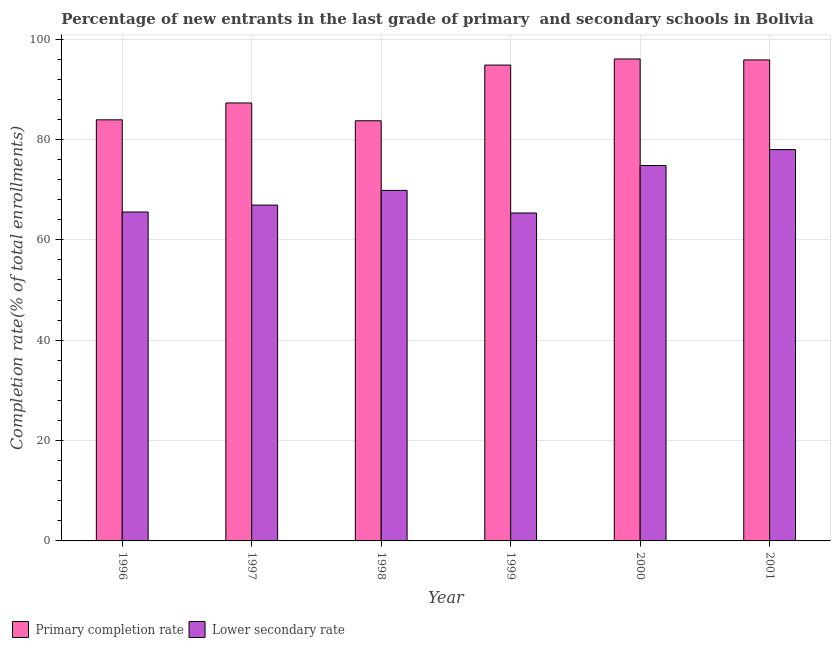Are the number of bars per tick equal to the number of legend labels?
Keep it short and to the point. Yes. How many bars are there on the 1st tick from the left?
Give a very brief answer. 2. How many bars are there on the 3rd tick from the right?
Provide a short and direct response. 2. In how many cases, is the number of bars for a given year not equal to the number of legend labels?
Provide a succinct answer. 0. What is the completion rate in primary schools in 1999?
Give a very brief answer. 94.83. Across all years, what is the maximum completion rate in secondary schools?
Your answer should be compact. 77.98. Across all years, what is the minimum completion rate in primary schools?
Offer a terse response. 83.73. In which year was the completion rate in secondary schools maximum?
Your answer should be compact. 2001. In which year was the completion rate in primary schools minimum?
Your response must be concise. 1998. What is the total completion rate in secondary schools in the graph?
Keep it short and to the point. 420.45. What is the difference between the completion rate in secondary schools in 1999 and that in 2000?
Provide a short and direct response. -9.46. What is the difference between the completion rate in secondary schools in 1997 and the completion rate in primary schools in 1998?
Offer a very short reply. -2.93. What is the average completion rate in primary schools per year?
Make the answer very short. 90.27. In how many years, is the completion rate in secondary schools greater than 72 %?
Make the answer very short. 2. What is the ratio of the completion rate in primary schools in 1997 to that in 2001?
Offer a terse response. 0.91. Is the difference between the completion rate in secondary schools in 1999 and 2000 greater than the difference between the completion rate in primary schools in 1999 and 2000?
Give a very brief answer. No. What is the difference between the highest and the second highest completion rate in secondary schools?
Provide a succinct answer. 3.18. What is the difference between the highest and the lowest completion rate in secondary schools?
Make the answer very short. 12.64. In how many years, is the completion rate in primary schools greater than the average completion rate in primary schools taken over all years?
Make the answer very short. 3. What does the 1st bar from the left in 1997 represents?
Provide a succinct answer. Primary completion rate. What does the 2nd bar from the right in 1996 represents?
Ensure brevity in your answer.  Primary completion rate. How many years are there in the graph?
Offer a very short reply. 6. What is the difference between two consecutive major ticks on the Y-axis?
Give a very brief answer. 20. Does the graph contain any zero values?
Your answer should be compact. No. Where does the legend appear in the graph?
Give a very brief answer. Bottom left. How many legend labels are there?
Ensure brevity in your answer.  2. What is the title of the graph?
Offer a terse response. Percentage of new entrants in the last grade of primary  and secondary schools in Bolivia. What is the label or title of the X-axis?
Offer a very short reply. Year. What is the label or title of the Y-axis?
Offer a very short reply. Completion rate(% of total enrollments). What is the Completion rate(% of total enrollments) in Primary completion rate in 1996?
Keep it short and to the point. 83.92. What is the Completion rate(% of total enrollments) in Lower secondary rate in 1996?
Provide a succinct answer. 65.54. What is the Completion rate(% of total enrollments) of Primary completion rate in 1997?
Keep it short and to the point. 87.28. What is the Completion rate(% of total enrollments) of Lower secondary rate in 1997?
Ensure brevity in your answer.  66.92. What is the Completion rate(% of total enrollments) in Primary completion rate in 1998?
Offer a very short reply. 83.73. What is the Completion rate(% of total enrollments) of Lower secondary rate in 1998?
Ensure brevity in your answer.  69.85. What is the Completion rate(% of total enrollments) in Primary completion rate in 1999?
Give a very brief answer. 94.83. What is the Completion rate(% of total enrollments) of Lower secondary rate in 1999?
Your answer should be very brief. 65.35. What is the Completion rate(% of total enrollments) of Primary completion rate in 2000?
Ensure brevity in your answer.  96.04. What is the Completion rate(% of total enrollments) in Lower secondary rate in 2000?
Make the answer very short. 74.8. What is the Completion rate(% of total enrollments) in Primary completion rate in 2001?
Make the answer very short. 95.85. What is the Completion rate(% of total enrollments) of Lower secondary rate in 2001?
Your response must be concise. 77.98. Across all years, what is the maximum Completion rate(% of total enrollments) in Primary completion rate?
Provide a succinct answer. 96.04. Across all years, what is the maximum Completion rate(% of total enrollments) of Lower secondary rate?
Give a very brief answer. 77.98. Across all years, what is the minimum Completion rate(% of total enrollments) of Primary completion rate?
Give a very brief answer. 83.73. Across all years, what is the minimum Completion rate(% of total enrollments) in Lower secondary rate?
Ensure brevity in your answer.  65.35. What is the total Completion rate(% of total enrollments) of Primary completion rate in the graph?
Your answer should be compact. 541.64. What is the total Completion rate(% of total enrollments) of Lower secondary rate in the graph?
Provide a succinct answer. 420.45. What is the difference between the Completion rate(% of total enrollments) in Primary completion rate in 1996 and that in 1997?
Give a very brief answer. -3.36. What is the difference between the Completion rate(% of total enrollments) in Lower secondary rate in 1996 and that in 1997?
Keep it short and to the point. -1.38. What is the difference between the Completion rate(% of total enrollments) in Primary completion rate in 1996 and that in 1998?
Make the answer very short. 0.19. What is the difference between the Completion rate(% of total enrollments) of Lower secondary rate in 1996 and that in 1998?
Offer a very short reply. -4.31. What is the difference between the Completion rate(% of total enrollments) in Primary completion rate in 1996 and that in 1999?
Provide a succinct answer. -10.91. What is the difference between the Completion rate(% of total enrollments) in Lower secondary rate in 1996 and that in 1999?
Offer a very short reply. 0.2. What is the difference between the Completion rate(% of total enrollments) of Primary completion rate in 1996 and that in 2000?
Offer a very short reply. -12.13. What is the difference between the Completion rate(% of total enrollments) of Lower secondary rate in 1996 and that in 2000?
Give a very brief answer. -9.26. What is the difference between the Completion rate(% of total enrollments) in Primary completion rate in 1996 and that in 2001?
Make the answer very short. -11.93. What is the difference between the Completion rate(% of total enrollments) of Lower secondary rate in 1996 and that in 2001?
Offer a terse response. -12.44. What is the difference between the Completion rate(% of total enrollments) of Primary completion rate in 1997 and that in 1998?
Your answer should be compact. 3.55. What is the difference between the Completion rate(% of total enrollments) in Lower secondary rate in 1997 and that in 1998?
Provide a short and direct response. -2.93. What is the difference between the Completion rate(% of total enrollments) in Primary completion rate in 1997 and that in 1999?
Ensure brevity in your answer.  -7.55. What is the difference between the Completion rate(% of total enrollments) of Lower secondary rate in 1997 and that in 1999?
Your answer should be very brief. 1.58. What is the difference between the Completion rate(% of total enrollments) of Primary completion rate in 1997 and that in 2000?
Ensure brevity in your answer.  -8.77. What is the difference between the Completion rate(% of total enrollments) of Lower secondary rate in 1997 and that in 2000?
Offer a terse response. -7.88. What is the difference between the Completion rate(% of total enrollments) of Primary completion rate in 1997 and that in 2001?
Make the answer very short. -8.57. What is the difference between the Completion rate(% of total enrollments) in Lower secondary rate in 1997 and that in 2001?
Your answer should be compact. -11.06. What is the difference between the Completion rate(% of total enrollments) of Primary completion rate in 1998 and that in 1999?
Your answer should be very brief. -11.1. What is the difference between the Completion rate(% of total enrollments) in Lower secondary rate in 1998 and that in 1999?
Make the answer very short. 4.51. What is the difference between the Completion rate(% of total enrollments) of Primary completion rate in 1998 and that in 2000?
Offer a very short reply. -12.31. What is the difference between the Completion rate(% of total enrollments) in Lower secondary rate in 1998 and that in 2000?
Ensure brevity in your answer.  -4.95. What is the difference between the Completion rate(% of total enrollments) of Primary completion rate in 1998 and that in 2001?
Offer a terse response. -12.12. What is the difference between the Completion rate(% of total enrollments) in Lower secondary rate in 1998 and that in 2001?
Your answer should be compact. -8.13. What is the difference between the Completion rate(% of total enrollments) of Primary completion rate in 1999 and that in 2000?
Provide a short and direct response. -1.21. What is the difference between the Completion rate(% of total enrollments) in Lower secondary rate in 1999 and that in 2000?
Keep it short and to the point. -9.46. What is the difference between the Completion rate(% of total enrollments) of Primary completion rate in 1999 and that in 2001?
Keep it short and to the point. -1.02. What is the difference between the Completion rate(% of total enrollments) of Lower secondary rate in 1999 and that in 2001?
Offer a terse response. -12.64. What is the difference between the Completion rate(% of total enrollments) in Primary completion rate in 2000 and that in 2001?
Your response must be concise. 0.19. What is the difference between the Completion rate(% of total enrollments) in Lower secondary rate in 2000 and that in 2001?
Your answer should be compact. -3.18. What is the difference between the Completion rate(% of total enrollments) in Primary completion rate in 1996 and the Completion rate(% of total enrollments) in Lower secondary rate in 1997?
Ensure brevity in your answer.  16.99. What is the difference between the Completion rate(% of total enrollments) of Primary completion rate in 1996 and the Completion rate(% of total enrollments) of Lower secondary rate in 1998?
Offer a terse response. 14.06. What is the difference between the Completion rate(% of total enrollments) of Primary completion rate in 1996 and the Completion rate(% of total enrollments) of Lower secondary rate in 1999?
Offer a terse response. 18.57. What is the difference between the Completion rate(% of total enrollments) of Primary completion rate in 1996 and the Completion rate(% of total enrollments) of Lower secondary rate in 2000?
Provide a short and direct response. 9.11. What is the difference between the Completion rate(% of total enrollments) of Primary completion rate in 1996 and the Completion rate(% of total enrollments) of Lower secondary rate in 2001?
Offer a very short reply. 5.93. What is the difference between the Completion rate(% of total enrollments) in Primary completion rate in 1997 and the Completion rate(% of total enrollments) in Lower secondary rate in 1998?
Ensure brevity in your answer.  17.42. What is the difference between the Completion rate(% of total enrollments) in Primary completion rate in 1997 and the Completion rate(% of total enrollments) in Lower secondary rate in 1999?
Provide a succinct answer. 21.93. What is the difference between the Completion rate(% of total enrollments) in Primary completion rate in 1997 and the Completion rate(% of total enrollments) in Lower secondary rate in 2000?
Provide a short and direct response. 12.47. What is the difference between the Completion rate(% of total enrollments) of Primary completion rate in 1997 and the Completion rate(% of total enrollments) of Lower secondary rate in 2001?
Your answer should be compact. 9.29. What is the difference between the Completion rate(% of total enrollments) in Primary completion rate in 1998 and the Completion rate(% of total enrollments) in Lower secondary rate in 1999?
Ensure brevity in your answer.  18.38. What is the difference between the Completion rate(% of total enrollments) of Primary completion rate in 1998 and the Completion rate(% of total enrollments) of Lower secondary rate in 2000?
Keep it short and to the point. 8.92. What is the difference between the Completion rate(% of total enrollments) in Primary completion rate in 1998 and the Completion rate(% of total enrollments) in Lower secondary rate in 2001?
Keep it short and to the point. 5.75. What is the difference between the Completion rate(% of total enrollments) in Primary completion rate in 1999 and the Completion rate(% of total enrollments) in Lower secondary rate in 2000?
Provide a succinct answer. 20.02. What is the difference between the Completion rate(% of total enrollments) of Primary completion rate in 1999 and the Completion rate(% of total enrollments) of Lower secondary rate in 2001?
Make the answer very short. 16.84. What is the difference between the Completion rate(% of total enrollments) in Primary completion rate in 2000 and the Completion rate(% of total enrollments) in Lower secondary rate in 2001?
Make the answer very short. 18.06. What is the average Completion rate(% of total enrollments) of Primary completion rate per year?
Your answer should be compact. 90.27. What is the average Completion rate(% of total enrollments) of Lower secondary rate per year?
Ensure brevity in your answer.  70.07. In the year 1996, what is the difference between the Completion rate(% of total enrollments) in Primary completion rate and Completion rate(% of total enrollments) in Lower secondary rate?
Provide a short and direct response. 18.37. In the year 1997, what is the difference between the Completion rate(% of total enrollments) in Primary completion rate and Completion rate(% of total enrollments) in Lower secondary rate?
Give a very brief answer. 20.35. In the year 1998, what is the difference between the Completion rate(% of total enrollments) of Primary completion rate and Completion rate(% of total enrollments) of Lower secondary rate?
Give a very brief answer. 13.88. In the year 1999, what is the difference between the Completion rate(% of total enrollments) in Primary completion rate and Completion rate(% of total enrollments) in Lower secondary rate?
Provide a short and direct response. 29.48. In the year 2000, what is the difference between the Completion rate(% of total enrollments) in Primary completion rate and Completion rate(% of total enrollments) in Lower secondary rate?
Your answer should be compact. 21.24. In the year 2001, what is the difference between the Completion rate(% of total enrollments) of Primary completion rate and Completion rate(% of total enrollments) of Lower secondary rate?
Make the answer very short. 17.87. What is the ratio of the Completion rate(% of total enrollments) of Primary completion rate in 1996 to that in 1997?
Provide a succinct answer. 0.96. What is the ratio of the Completion rate(% of total enrollments) in Lower secondary rate in 1996 to that in 1997?
Offer a very short reply. 0.98. What is the ratio of the Completion rate(% of total enrollments) in Primary completion rate in 1996 to that in 1998?
Offer a terse response. 1. What is the ratio of the Completion rate(% of total enrollments) of Lower secondary rate in 1996 to that in 1998?
Ensure brevity in your answer.  0.94. What is the ratio of the Completion rate(% of total enrollments) in Primary completion rate in 1996 to that in 1999?
Offer a terse response. 0.88. What is the ratio of the Completion rate(% of total enrollments) of Lower secondary rate in 1996 to that in 1999?
Your response must be concise. 1. What is the ratio of the Completion rate(% of total enrollments) of Primary completion rate in 1996 to that in 2000?
Your answer should be very brief. 0.87. What is the ratio of the Completion rate(% of total enrollments) in Lower secondary rate in 1996 to that in 2000?
Keep it short and to the point. 0.88. What is the ratio of the Completion rate(% of total enrollments) of Primary completion rate in 1996 to that in 2001?
Provide a short and direct response. 0.88. What is the ratio of the Completion rate(% of total enrollments) in Lower secondary rate in 1996 to that in 2001?
Provide a succinct answer. 0.84. What is the ratio of the Completion rate(% of total enrollments) in Primary completion rate in 1997 to that in 1998?
Keep it short and to the point. 1.04. What is the ratio of the Completion rate(% of total enrollments) in Lower secondary rate in 1997 to that in 1998?
Your response must be concise. 0.96. What is the ratio of the Completion rate(% of total enrollments) of Primary completion rate in 1997 to that in 1999?
Make the answer very short. 0.92. What is the ratio of the Completion rate(% of total enrollments) of Lower secondary rate in 1997 to that in 1999?
Provide a succinct answer. 1.02. What is the ratio of the Completion rate(% of total enrollments) in Primary completion rate in 1997 to that in 2000?
Ensure brevity in your answer.  0.91. What is the ratio of the Completion rate(% of total enrollments) of Lower secondary rate in 1997 to that in 2000?
Provide a succinct answer. 0.89. What is the ratio of the Completion rate(% of total enrollments) of Primary completion rate in 1997 to that in 2001?
Provide a short and direct response. 0.91. What is the ratio of the Completion rate(% of total enrollments) of Lower secondary rate in 1997 to that in 2001?
Make the answer very short. 0.86. What is the ratio of the Completion rate(% of total enrollments) in Primary completion rate in 1998 to that in 1999?
Provide a succinct answer. 0.88. What is the ratio of the Completion rate(% of total enrollments) in Lower secondary rate in 1998 to that in 1999?
Offer a very short reply. 1.07. What is the ratio of the Completion rate(% of total enrollments) in Primary completion rate in 1998 to that in 2000?
Your response must be concise. 0.87. What is the ratio of the Completion rate(% of total enrollments) in Lower secondary rate in 1998 to that in 2000?
Provide a succinct answer. 0.93. What is the ratio of the Completion rate(% of total enrollments) of Primary completion rate in 1998 to that in 2001?
Ensure brevity in your answer.  0.87. What is the ratio of the Completion rate(% of total enrollments) in Lower secondary rate in 1998 to that in 2001?
Offer a very short reply. 0.9. What is the ratio of the Completion rate(% of total enrollments) of Primary completion rate in 1999 to that in 2000?
Your answer should be very brief. 0.99. What is the ratio of the Completion rate(% of total enrollments) in Lower secondary rate in 1999 to that in 2000?
Provide a succinct answer. 0.87. What is the ratio of the Completion rate(% of total enrollments) in Primary completion rate in 1999 to that in 2001?
Offer a terse response. 0.99. What is the ratio of the Completion rate(% of total enrollments) of Lower secondary rate in 1999 to that in 2001?
Give a very brief answer. 0.84. What is the ratio of the Completion rate(% of total enrollments) of Lower secondary rate in 2000 to that in 2001?
Provide a short and direct response. 0.96. What is the difference between the highest and the second highest Completion rate(% of total enrollments) in Primary completion rate?
Your answer should be very brief. 0.19. What is the difference between the highest and the second highest Completion rate(% of total enrollments) in Lower secondary rate?
Ensure brevity in your answer.  3.18. What is the difference between the highest and the lowest Completion rate(% of total enrollments) of Primary completion rate?
Your answer should be compact. 12.31. What is the difference between the highest and the lowest Completion rate(% of total enrollments) of Lower secondary rate?
Make the answer very short. 12.64. 